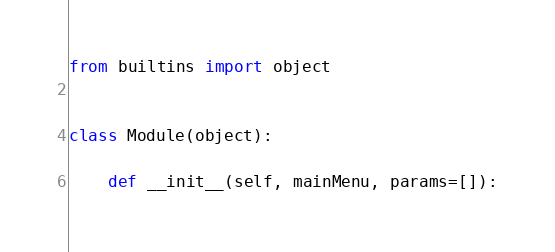Convert code to text. <code><loc_0><loc_0><loc_500><loc_500><_Python_>from builtins import object


class Module(object):

    def __init__(self, mainMenu, params=[]):
</code> 